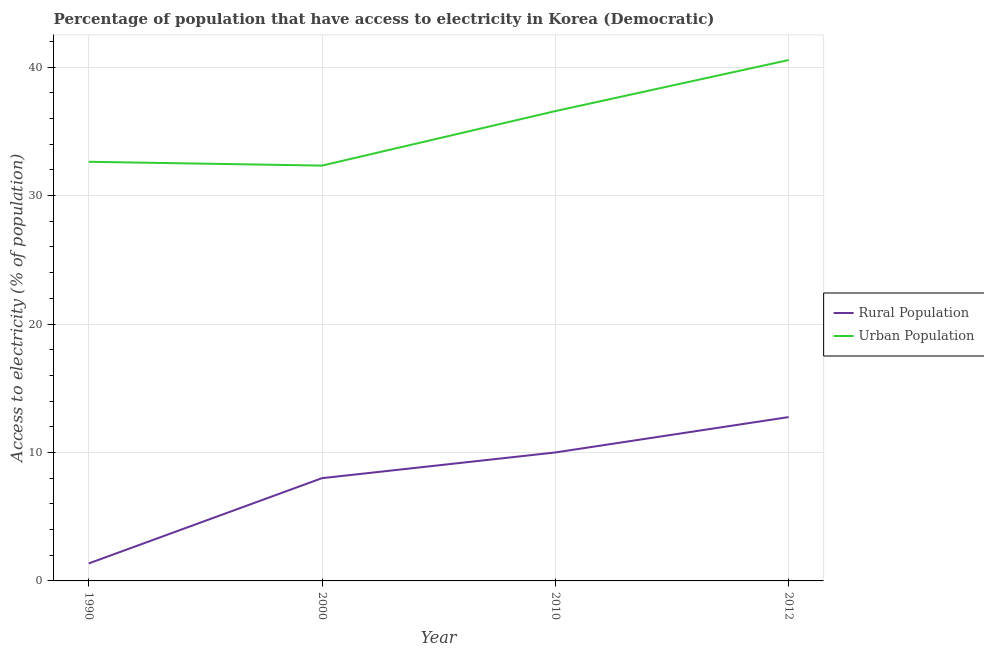How many different coloured lines are there?
Your response must be concise. 2. What is the percentage of rural population having access to electricity in 1990?
Your response must be concise. 1.36. Across all years, what is the maximum percentage of urban population having access to electricity?
Provide a short and direct response. 40.55. Across all years, what is the minimum percentage of urban population having access to electricity?
Make the answer very short. 32.33. In which year was the percentage of rural population having access to electricity maximum?
Your answer should be compact. 2012. In which year was the percentage of urban population having access to electricity minimum?
Offer a terse response. 2000. What is the total percentage of urban population having access to electricity in the graph?
Your response must be concise. 142.08. What is the difference between the percentage of rural population having access to electricity in 1990 and that in 2012?
Provide a succinct answer. -11.39. What is the difference between the percentage of rural population having access to electricity in 1990 and the percentage of urban population having access to electricity in 2000?
Provide a short and direct response. -30.97. What is the average percentage of rural population having access to electricity per year?
Offer a very short reply. 8.03. In the year 2010, what is the difference between the percentage of urban population having access to electricity and percentage of rural population having access to electricity?
Your response must be concise. 26.57. In how many years, is the percentage of rural population having access to electricity greater than 6 %?
Offer a very short reply. 3. What is the ratio of the percentage of urban population having access to electricity in 2010 to that in 2012?
Offer a very short reply. 0.9. Is the percentage of urban population having access to electricity in 2000 less than that in 2012?
Keep it short and to the point. Yes. What is the difference between the highest and the second highest percentage of rural population having access to electricity?
Offer a very short reply. 2.75. What is the difference between the highest and the lowest percentage of urban population having access to electricity?
Provide a succinct answer. 8.22. In how many years, is the percentage of urban population having access to electricity greater than the average percentage of urban population having access to electricity taken over all years?
Ensure brevity in your answer.  2. Is the sum of the percentage of urban population having access to electricity in 2000 and 2010 greater than the maximum percentage of rural population having access to electricity across all years?
Ensure brevity in your answer.  Yes. Does the percentage of rural population having access to electricity monotonically increase over the years?
Provide a short and direct response. Yes. Is the percentage of rural population having access to electricity strictly less than the percentage of urban population having access to electricity over the years?
Give a very brief answer. Yes. How are the legend labels stacked?
Give a very brief answer. Vertical. What is the title of the graph?
Your response must be concise. Percentage of population that have access to electricity in Korea (Democratic). Does "Technicians" appear as one of the legend labels in the graph?
Offer a very short reply. No. What is the label or title of the Y-axis?
Offer a very short reply. Access to electricity (% of population). What is the Access to electricity (% of population) in Rural Population in 1990?
Provide a short and direct response. 1.36. What is the Access to electricity (% of population) in Urban Population in 1990?
Ensure brevity in your answer.  32.63. What is the Access to electricity (% of population) of Urban Population in 2000?
Your answer should be compact. 32.33. What is the Access to electricity (% of population) in Urban Population in 2010?
Give a very brief answer. 36.57. What is the Access to electricity (% of population) in Rural Population in 2012?
Offer a terse response. 12.75. What is the Access to electricity (% of population) of Urban Population in 2012?
Your answer should be very brief. 40.55. Across all years, what is the maximum Access to electricity (% of population) in Rural Population?
Your answer should be compact. 12.75. Across all years, what is the maximum Access to electricity (% of population) of Urban Population?
Your response must be concise. 40.55. Across all years, what is the minimum Access to electricity (% of population) of Rural Population?
Provide a succinct answer. 1.36. Across all years, what is the minimum Access to electricity (% of population) of Urban Population?
Provide a short and direct response. 32.33. What is the total Access to electricity (% of population) in Rural Population in the graph?
Keep it short and to the point. 32.11. What is the total Access to electricity (% of population) of Urban Population in the graph?
Your answer should be very brief. 142.08. What is the difference between the Access to electricity (% of population) in Rural Population in 1990 and that in 2000?
Offer a very short reply. -6.64. What is the difference between the Access to electricity (% of population) in Urban Population in 1990 and that in 2000?
Provide a short and direct response. 0.3. What is the difference between the Access to electricity (% of population) in Rural Population in 1990 and that in 2010?
Your answer should be very brief. -8.64. What is the difference between the Access to electricity (% of population) in Urban Population in 1990 and that in 2010?
Your answer should be very brief. -3.95. What is the difference between the Access to electricity (% of population) of Rural Population in 1990 and that in 2012?
Give a very brief answer. -11.39. What is the difference between the Access to electricity (% of population) of Urban Population in 1990 and that in 2012?
Provide a succinct answer. -7.92. What is the difference between the Access to electricity (% of population) of Rural Population in 2000 and that in 2010?
Your answer should be very brief. -2. What is the difference between the Access to electricity (% of population) of Urban Population in 2000 and that in 2010?
Give a very brief answer. -4.24. What is the difference between the Access to electricity (% of population) of Rural Population in 2000 and that in 2012?
Provide a succinct answer. -4.75. What is the difference between the Access to electricity (% of population) of Urban Population in 2000 and that in 2012?
Your answer should be very brief. -8.22. What is the difference between the Access to electricity (% of population) of Rural Population in 2010 and that in 2012?
Make the answer very short. -2.75. What is the difference between the Access to electricity (% of population) in Urban Population in 2010 and that in 2012?
Your response must be concise. -3.97. What is the difference between the Access to electricity (% of population) of Rural Population in 1990 and the Access to electricity (% of population) of Urban Population in 2000?
Provide a short and direct response. -30.97. What is the difference between the Access to electricity (% of population) in Rural Population in 1990 and the Access to electricity (% of population) in Urban Population in 2010?
Your answer should be compact. -35.21. What is the difference between the Access to electricity (% of population) of Rural Population in 1990 and the Access to electricity (% of population) of Urban Population in 2012?
Make the answer very short. -39.19. What is the difference between the Access to electricity (% of population) in Rural Population in 2000 and the Access to electricity (% of population) in Urban Population in 2010?
Provide a short and direct response. -28.57. What is the difference between the Access to electricity (% of population) in Rural Population in 2000 and the Access to electricity (% of population) in Urban Population in 2012?
Offer a terse response. -32.55. What is the difference between the Access to electricity (% of population) in Rural Population in 2010 and the Access to electricity (% of population) in Urban Population in 2012?
Offer a very short reply. -30.55. What is the average Access to electricity (% of population) in Rural Population per year?
Provide a succinct answer. 8.03. What is the average Access to electricity (% of population) in Urban Population per year?
Your response must be concise. 35.52. In the year 1990, what is the difference between the Access to electricity (% of population) in Rural Population and Access to electricity (% of population) in Urban Population?
Your response must be concise. -31.27. In the year 2000, what is the difference between the Access to electricity (% of population) of Rural Population and Access to electricity (% of population) of Urban Population?
Provide a succinct answer. -24.33. In the year 2010, what is the difference between the Access to electricity (% of population) of Rural Population and Access to electricity (% of population) of Urban Population?
Make the answer very short. -26.57. In the year 2012, what is the difference between the Access to electricity (% of population) of Rural Population and Access to electricity (% of population) of Urban Population?
Keep it short and to the point. -27.79. What is the ratio of the Access to electricity (% of population) of Rural Population in 1990 to that in 2000?
Your response must be concise. 0.17. What is the ratio of the Access to electricity (% of population) of Urban Population in 1990 to that in 2000?
Keep it short and to the point. 1.01. What is the ratio of the Access to electricity (% of population) of Rural Population in 1990 to that in 2010?
Provide a short and direct response. 0.14. What is the ratio of the Access to electricity (% of population) in Urban Population in 1990 to that in 2010?
Offer a terse response. 0.89. What is the ratio of the Access to electricity (% of population) in Rural Population in 1990 to that in 2012?
Your answer should be very brief. 0.11. What is the ratio of the Access to electricity (% of population) of Urban Population in 1990 to that in 2012?
Ensure brevity in your answer.  0.8. What is the ratio of the Access to electricity (% of population) in Urban Population in 2000 to that in 2010?
Your answer should be compact. 0.88. What is the ratio of the Access to electricity (% of population) in Rural Population in 2000 to that in 2012?
Keep it short and to the point. 0.63. What is the ratio of the Access to electricity (% of population) of Urban Population in 2000 to that in 2012?
Your response must be concise. 0.8. What is the ratio of the Access to electricity (% of population) in Rural Population in 2010 to that in 2012?
Make the answer very short. 0.78. What is the ratio of the Access to electricity (% of population) in Urban Population in 2010 to that in 2012?
Your response must be concise. 0.9. What is the difference between the highest and the second highest Access to electricity (% of population) of Rural Population?
Keep it short and to the point. 2.75. What is the difference between the highest and the second highest Access to electricity (% of population) of Urban Population?
Your response must be concise. 3.97. What is the difference between the highest and the lowest Access to electricity (% of population) of Rural Population?
Provide a succinct answer. 11.39. What is the difference between the highest and the lowest Access to electricity (% of population) of Urban Population?
Make the answer very short. 8.22. 